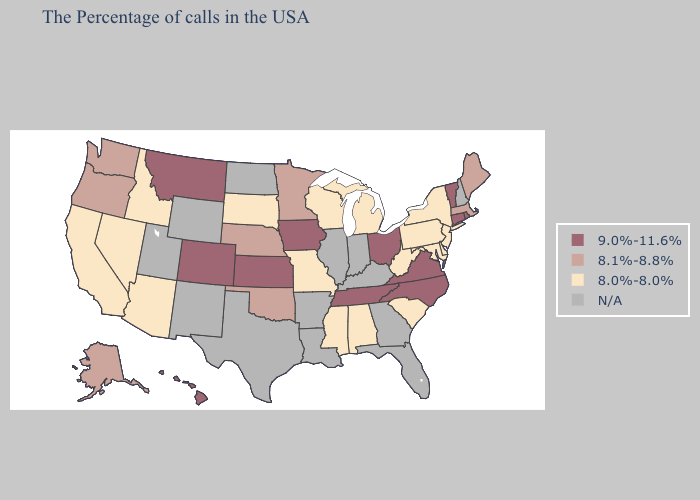What is the value of Nebraska?
Concise answer only. 8.1%-8.8%. Name the states that have a value in the range N/A?
Write a very short answer. New Hampshire, Florida, Georgia, Kentucky, Indiana, Illinois, Louisiana, Arkansas, Texas, North Dakota, Wyoming, New Mexico, Utah. Name the states that have a value in the range N/A?
Short answer required. New Hampshire, Florida, Georgia, Kentucky, Indiana, Illinois, Louisiana, Arkansas, Texas, North Dakota, Wyoming, New Mexico, Utah. Does the map have missing data?
Quick response, please. Yes. Which states have the lowest value in the West?
Write a very short answer. Arizona, Idaho, Nevada, California. How many symbols are there in the legend?
Answer briefly. 4. Name the states that have a value in the range 9.0%-11.6%?
Concise answer only. Rhode Island, Vermont, Connecticut, Virginia, North Carolina, Ohio, Tennessee, Iowa, Kansas, Colorado, Montana, Hawaii. Among the states that border South Dakota , does Iowa have the lowest value?
Answer briefly. No. Does the first symbol in the legend represent the smallest category?
Short answer required. No. What is the value of West Virginia?
Write a very short answer. 8.0%-8.0%. What is the value of Alaska?
Be succinct. 8.1%-8.8%. What is the value of Texas?
Short answer required. N/A. Does Tennessee have the lowest value in the USA?
Short answer required. No. What is the value of Nevada?
Keep it brief. 8.0%-8.0%. 